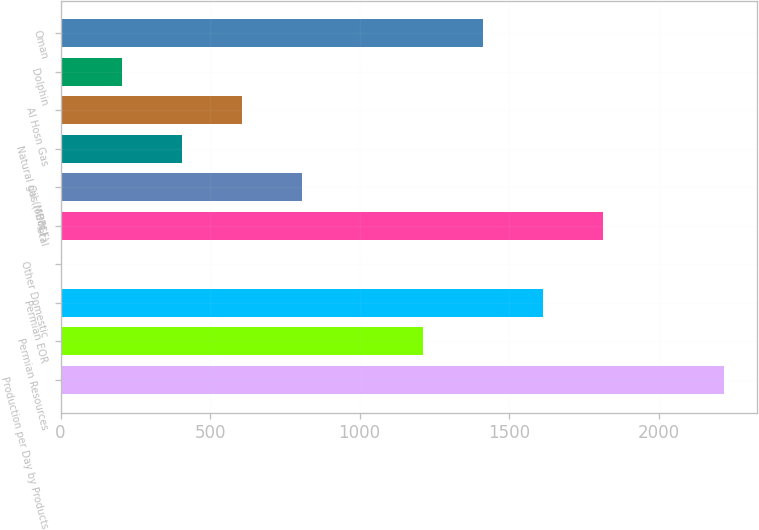<chart> <loc_0><loc_0><loc_500><loc_500><bar_chart><fcel>Production per Day by Products<fcel>Permian Resources<fcel>Permian EOR<fcel>Other Domestic<fcel>Total<fcel>Oil (MBBL)<fcel>Natural gas (MMCF)<fcel>Al Hosn Gas<fcel>Dolphin<fcel>Oman<nl><fcel>2217.2<fcel>1211.2<fcel>1613.6<fcel>4<fcel>1814.8<fcel>808.8<fcel>406.4<fcel>607.6<fcel>205.2<fcel>1412.4<nl></chart> 